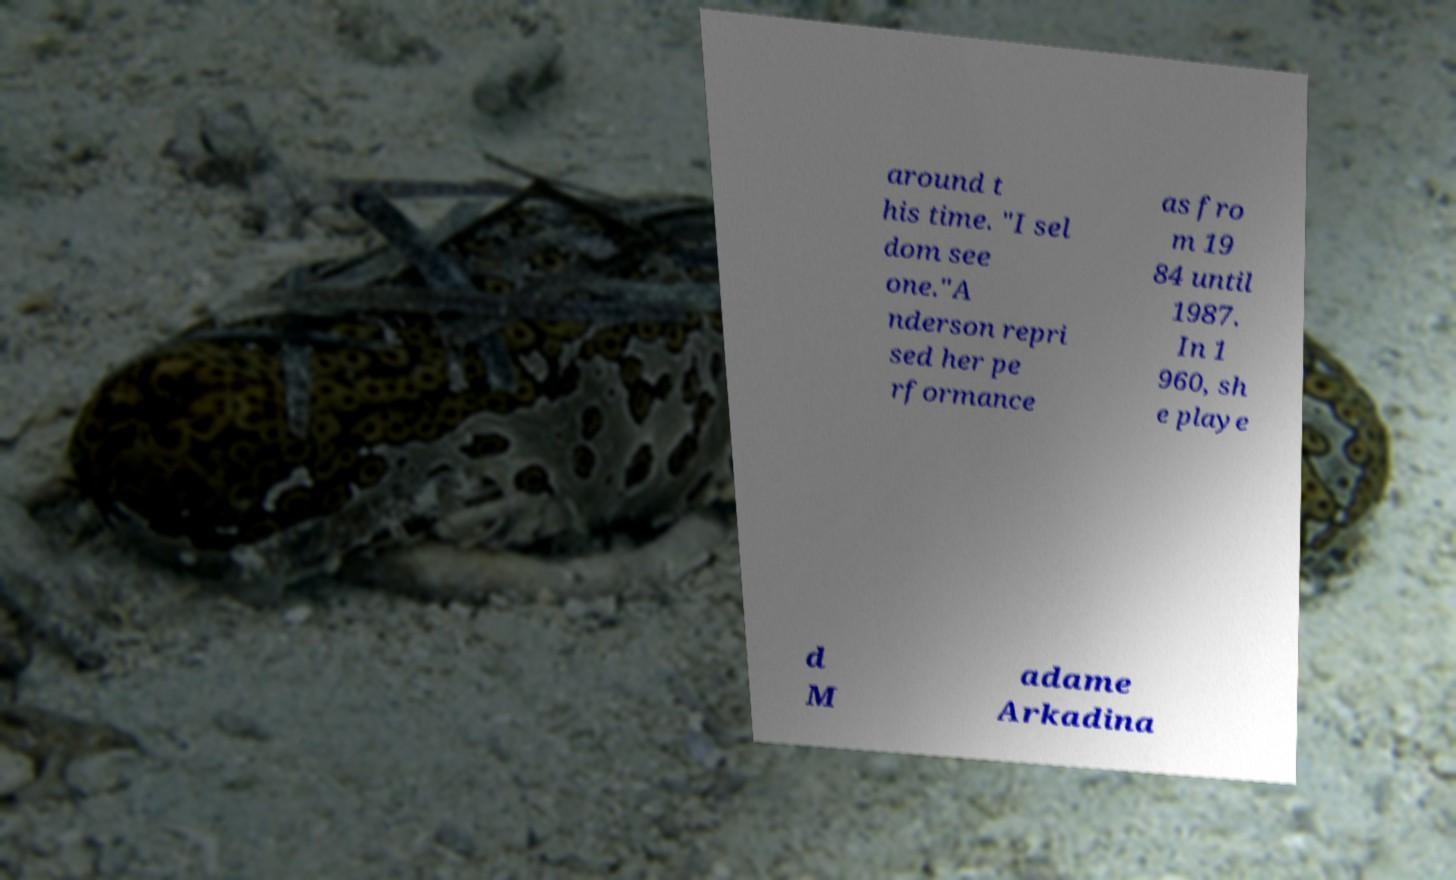I need the written content from this picture converted into text. Can you do that? around t his time. "I sel dom see one."A nderson repri sed her pe rformance as fro m 19 84 until 1987. In 1 960, sh e playe d M adame Arkadina 